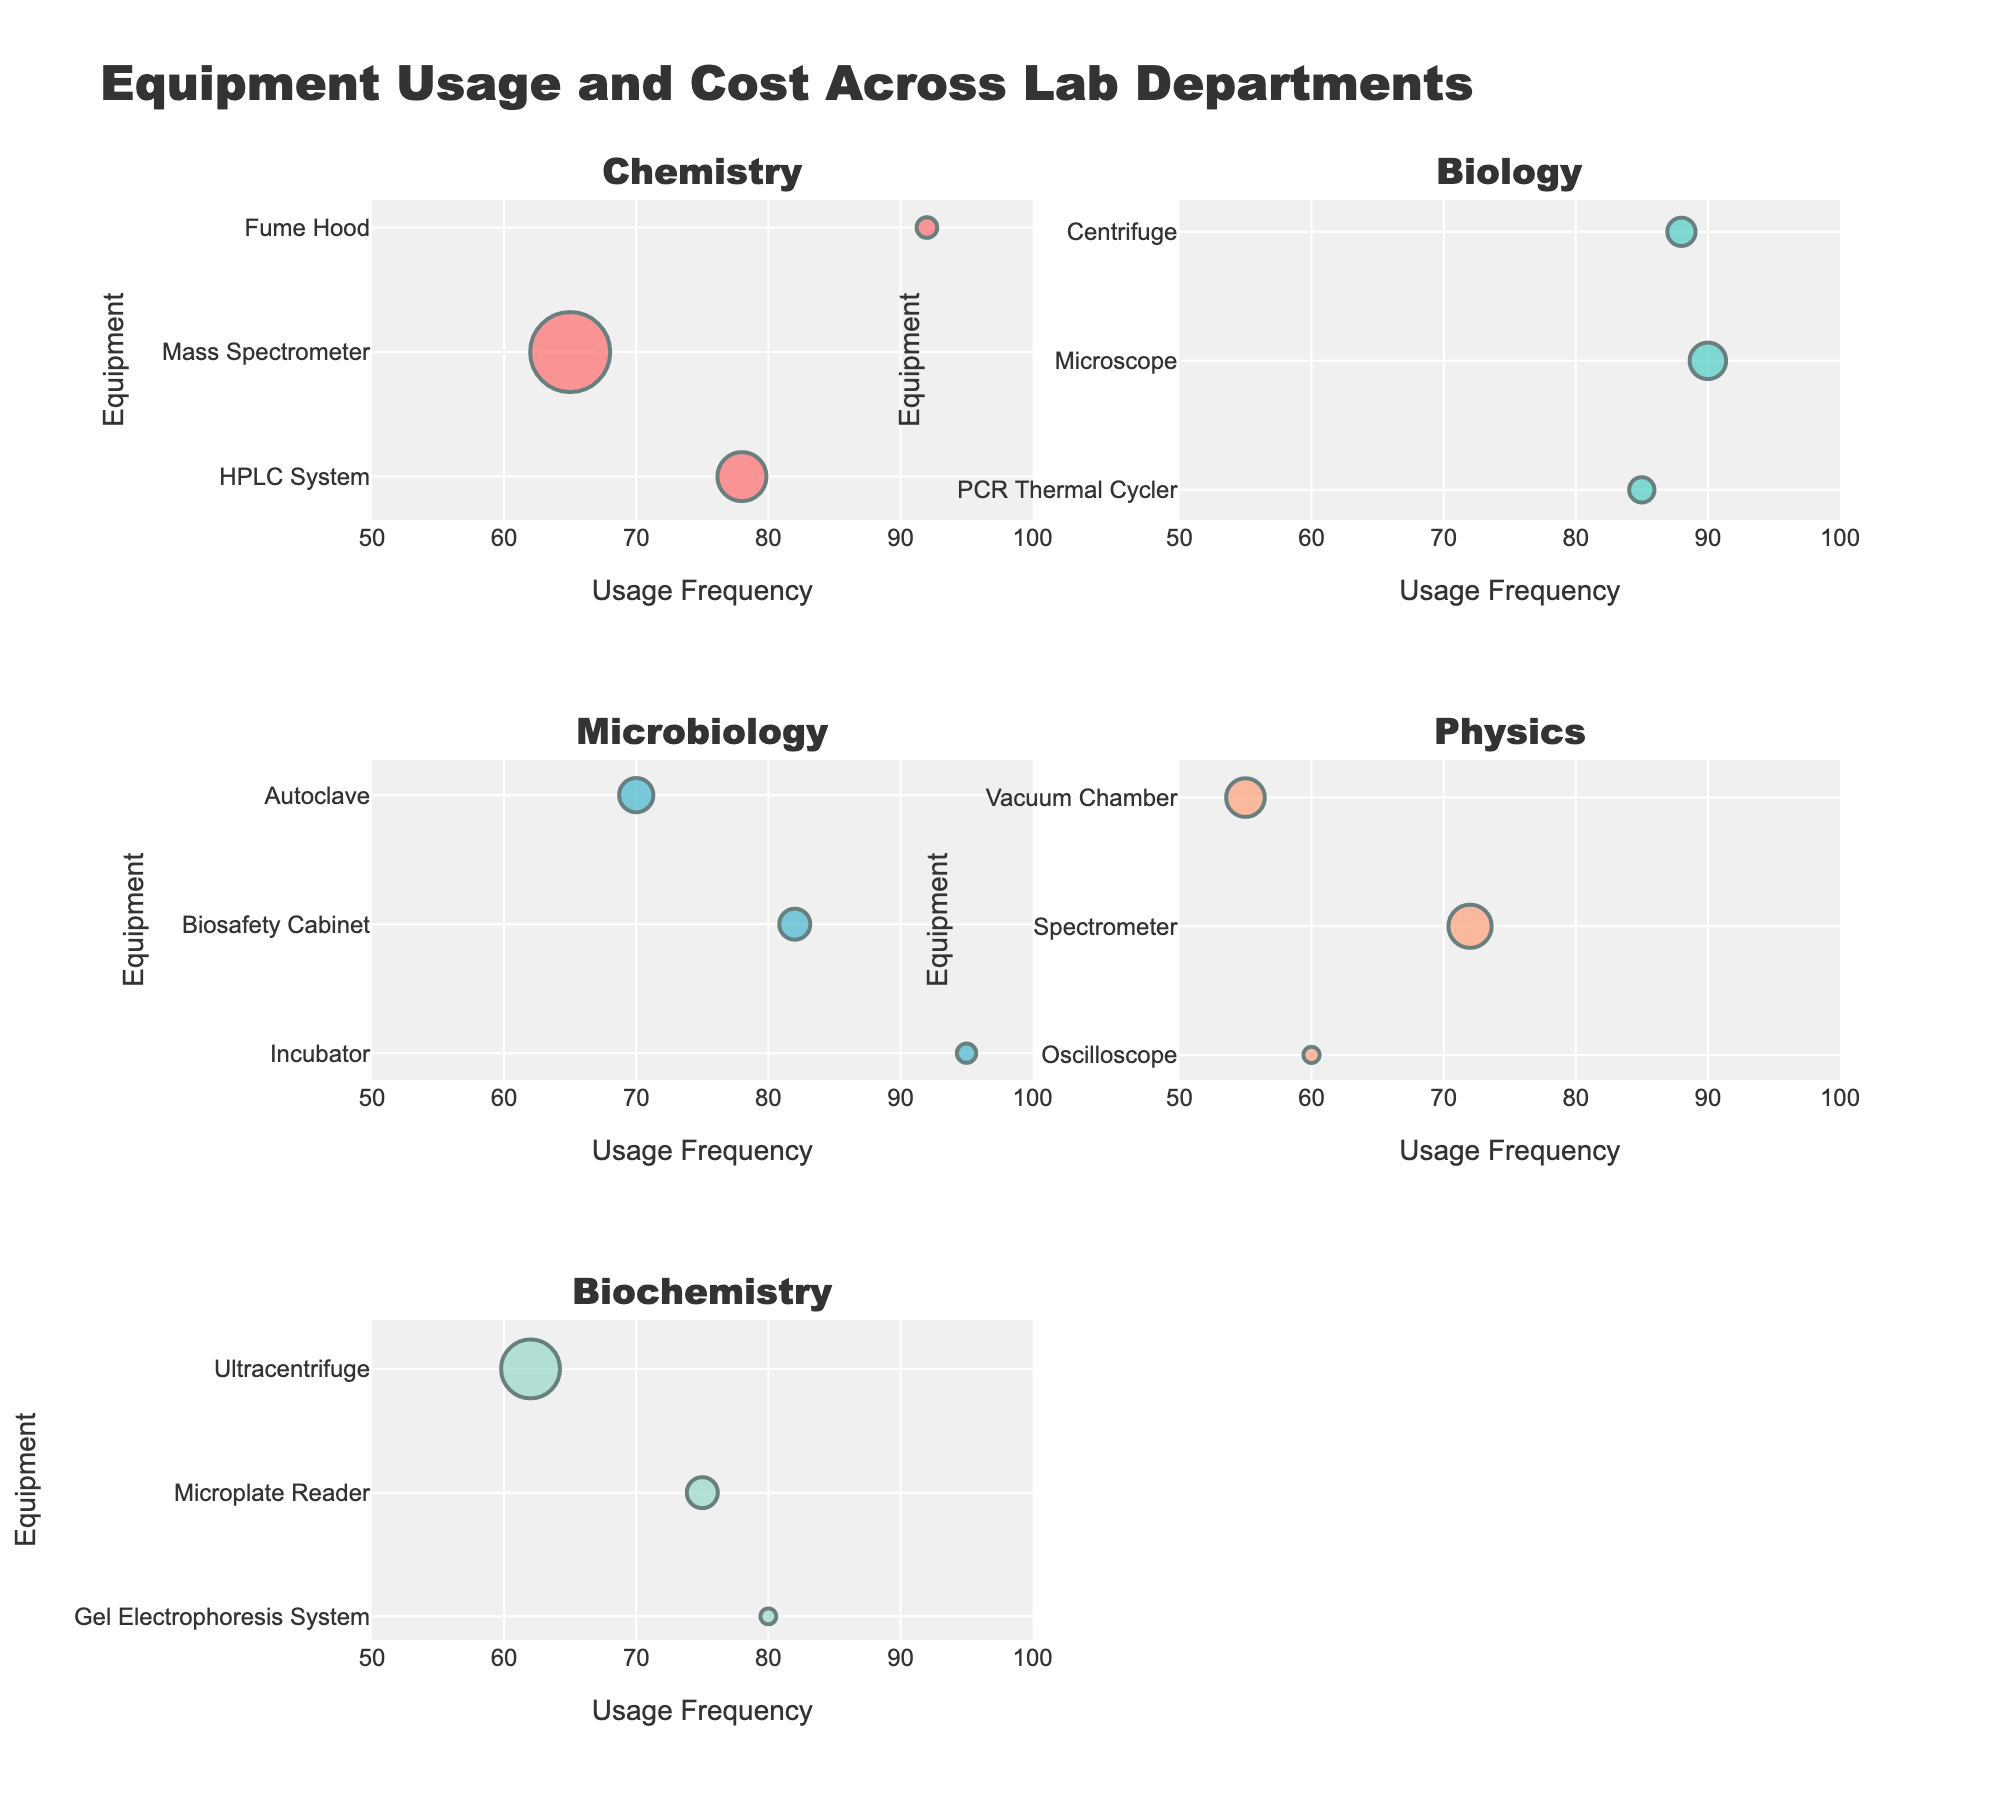Which department has the equipment with the highest usage frequency? The equipment with the highest usage frequency is the Incubator in the Microbiology department, which has a usage frequency of 95.
Answer: Microbiology What's the most expensive equipment in the Chemistry department? By observing the bubble sizes within the Chemistry subplot, the Mass Spectrometer has the largest bubble, indicating it has the highest cost of $120,000.
Answer: Mass Spectrometer Compare the costs of the PCR Thermal Cycler in Biology and the Fume Hood in Chemistry. Which one is more expensive? The PCR Thermal Cycler costs $12,000 while the Fume Hood costs $8,000, indicating that the PCR Thermal Cycler is more expensive.
Answer: PCR Thermal Cycler Which department has the most variation in usage frequency? By examining the range of usage frequencies in each subplot, the Physics department shows a wide range from 55 (Vacuum Chamber) to 72 (Spectrometer).
Answer: Physics Identify the equipment with the lowest usage frequency overall and state its department. The Vacuum Chamber in the Physics department has the lowest usage frequency at 55.
Answer: Vacuum Chamber, Physics Which equipment in the Biochemistry department has the highest cost? Observing the bubble sizes in the Biochemistry subplot, the Ultracentrifuge has the largest bubble, indicating the highest cost of $65,000.
Answer: Ultracentrifuge Compare the usage frequencies of the Oscilloscope in Physics and the Microscope in Biology. The usage frequency of the Oscilloscope is 60, whereas the Microscope has a usage frequency of 90, so the Microscope has a higher usage frequency.
Answer: Microscope What is the total cost of all equipment in the Chemistry department? Summing up the costs of the Chemistry equipment: HPLC System ($45,000) + Mass Spectrometer ($120,000) + Fume Hood ($8,000) = $173,000.
Answer: $173,000 What's the average usage frequency of equipment in the Biochemistry department? The usage frequencies are 80 (Gel Electrophoresis System), 75 (Microplate Reader), and 62 (Ultracentrifuge). The average is calculated as (80 + 75 + 62) / 3 = 72.33.
Answer: 72.33 Which equipment item has the largest bubble size in the Biology department? Based on the bubble sizes within the Biology subplot, the Microscope has the largest bubble size, indicating it has the highest cost in the department.
Answer: Microscope 